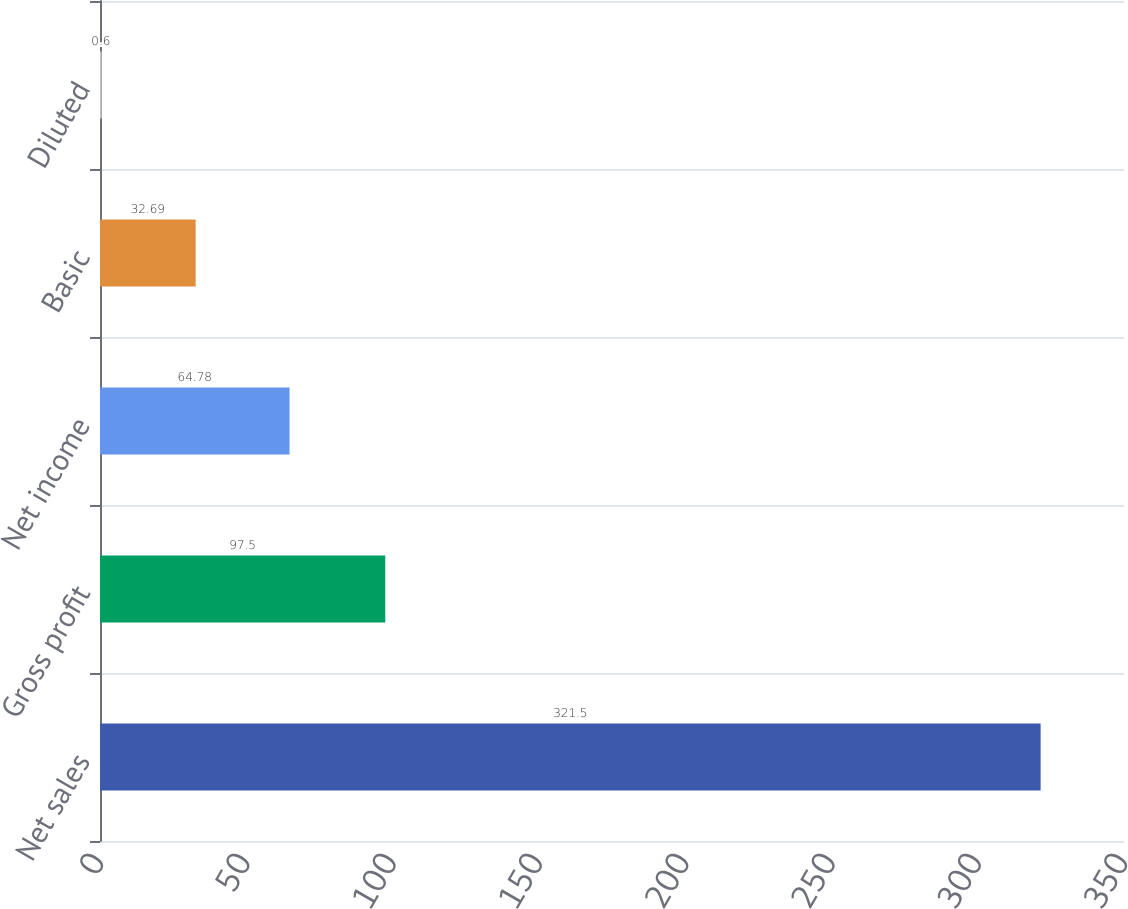Convert chart to OTSL. <chart><loc_0><loc_0><loc_500><loc_500><bar_chart><fcel>Net sales<fcel>Gross profit<fcel>Net income<fcel>Basic<fcel>Diluted<nl><fcel>321.5<fcel>97.5<fcel>64.78<fcel>32.69<fcel>0.6<nl></chart> 